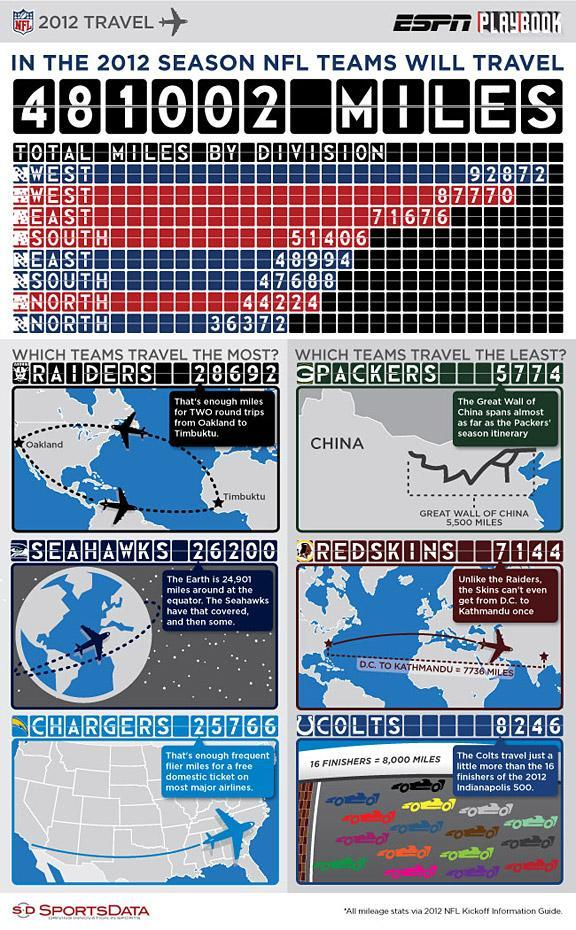How many miles were travelled by the NFC South teams during the 2012 NFL season?
Answer the question with a short phrase. 47688 Which NFL team has travelled the most in the 2012 NFL season? RAIDERS How many miles were travelled by the AFC East teams during the 2012 NFL season? 71676 Which NFL team has travelled the second-most among the most travelled teams in 2012 NFL season? SEAHAWKS How many divisions are in NFC? 4 Which NFC division has travelled the least in the 2012 NFL season? NORTH How many miles were travelled by the 'Redskins' during the 2012 NFL season? 7144 Which NFL team has travelled the least in the 2012 NFL season? GPACKERS Which AFC division has travelled the most in the 2012 NFL season? WEST 